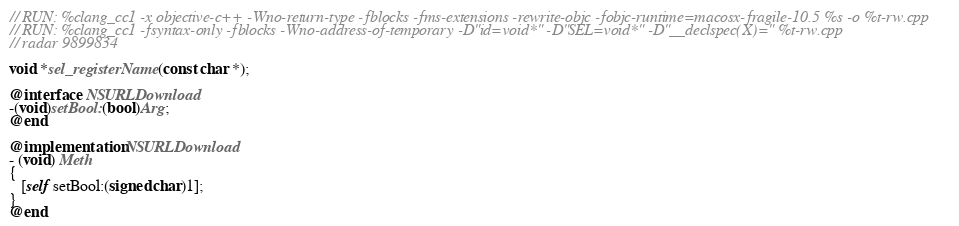<code> <loc_0><loc_0><loc_500><loc_500><_ObjectiveC_>// RUN: %clang_cc1 -x objective-c++ -Wno-return-type -fblocks -fms-extensions -rewrite-objc -fobjc-runtime=macosx-fragile-10.5 %s -o %t-rw.cpp
// RUN: %clang_cc1 -fsyntax-only -fblocks -Wno-address-of-temporary -D"id=void*" -D"SEL=void*" -D"__declspec(X)=" %t-rw.cpp
// radar 9899834

void *sel_registerName(const char *);

@interface  NSURLDownload
-(void)setBool:(bool)Arg;
@end

@implementation NSURLDownload
- (void) Meth
{
   [self setBool:(signed char)1];
}
@end

</code> 